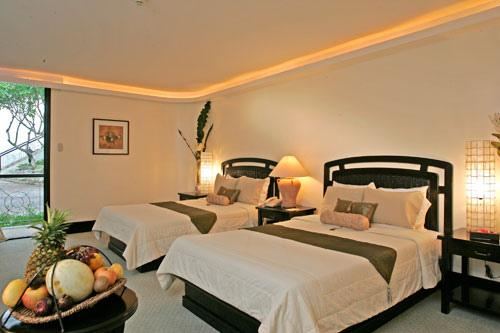What is the most likely level of this room? ground 